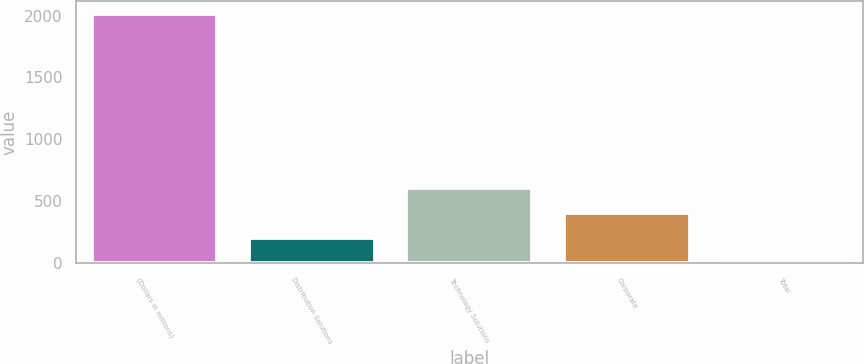Convert chart to OTSL. <chart><loc_0><loc_0><loc_500><loc_500><bar_chart><fcel>(Dollars in millions)<fcel>Distribution Solutions<fcel>Technology Solutions<fcel>Corporate<fcel>Total<nl><fcel>2016<fcel>208.8<fcel>610.4<fcel>409.6<fcel>8<nl></chart> 